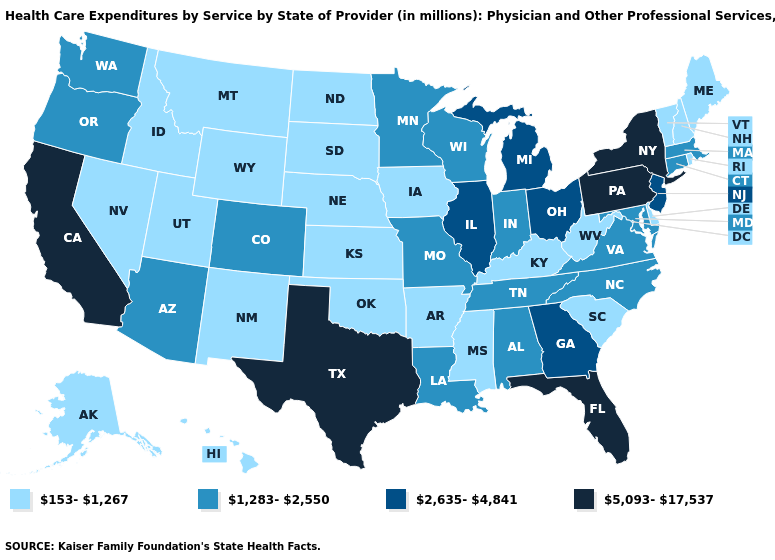Name the states that have a value in the range 2,635-4,841?
Write a very short answer. Georgia, Illinois, Michigan, New Jersey, Ohio. What is the highest value in states that border New York?
Write a very short answer. 5,093-17,537. Name the states that have a value in the range 153-1,267?
Short answer required. Alaska, Arkansas, Delaware, Hawaii, Idaho, Iowa, Kansas, Kentucky, Maine, Mississippi, Montana, Nebraska, Nevada, New Hampshire, New Mexico, North Dakota, Oklahoma, Rhode Island, South Carolina, South Dakota, Utah, Vermont, West Virginia, Wyoming. Does Idaho have the highest value in the West?
Be succinct. No. What is the highest value in the USA?
Concise answer only. 5,093-17,537. What is the value of North Carolina?
Quick response, please. 1,283-2,550. Does Texas have the highest value in the USA?
Be succinct. Yes. Which states have the highest value in the USA?
Write a very short answer. California, Florida, New York, Pennsylvania, Texas. Name the states that have a value in the range 1,283-2,550?
Answer briefly. Alabama, Arizona, Colorado, Connecticut, Indiana, Louisiana, Maryland, Massachusetts, Minnesota, Missouri, North Carolina, Oregon, Tennessee, Virginia, Washington, Wisconsin. Does Texas have the highest value in the South?
Answer briefly. Yes. What is the value of Montana?
Quick response, please. 153-1,267. Does the first symbol in the legend represent the smallest category?
Short answer required. Yes. What is the value of Utah?
Write a very short answer. 153-1,267. What is the lowest value in states that border New Jersey?
Give a very brief answer. 153-1,267. 